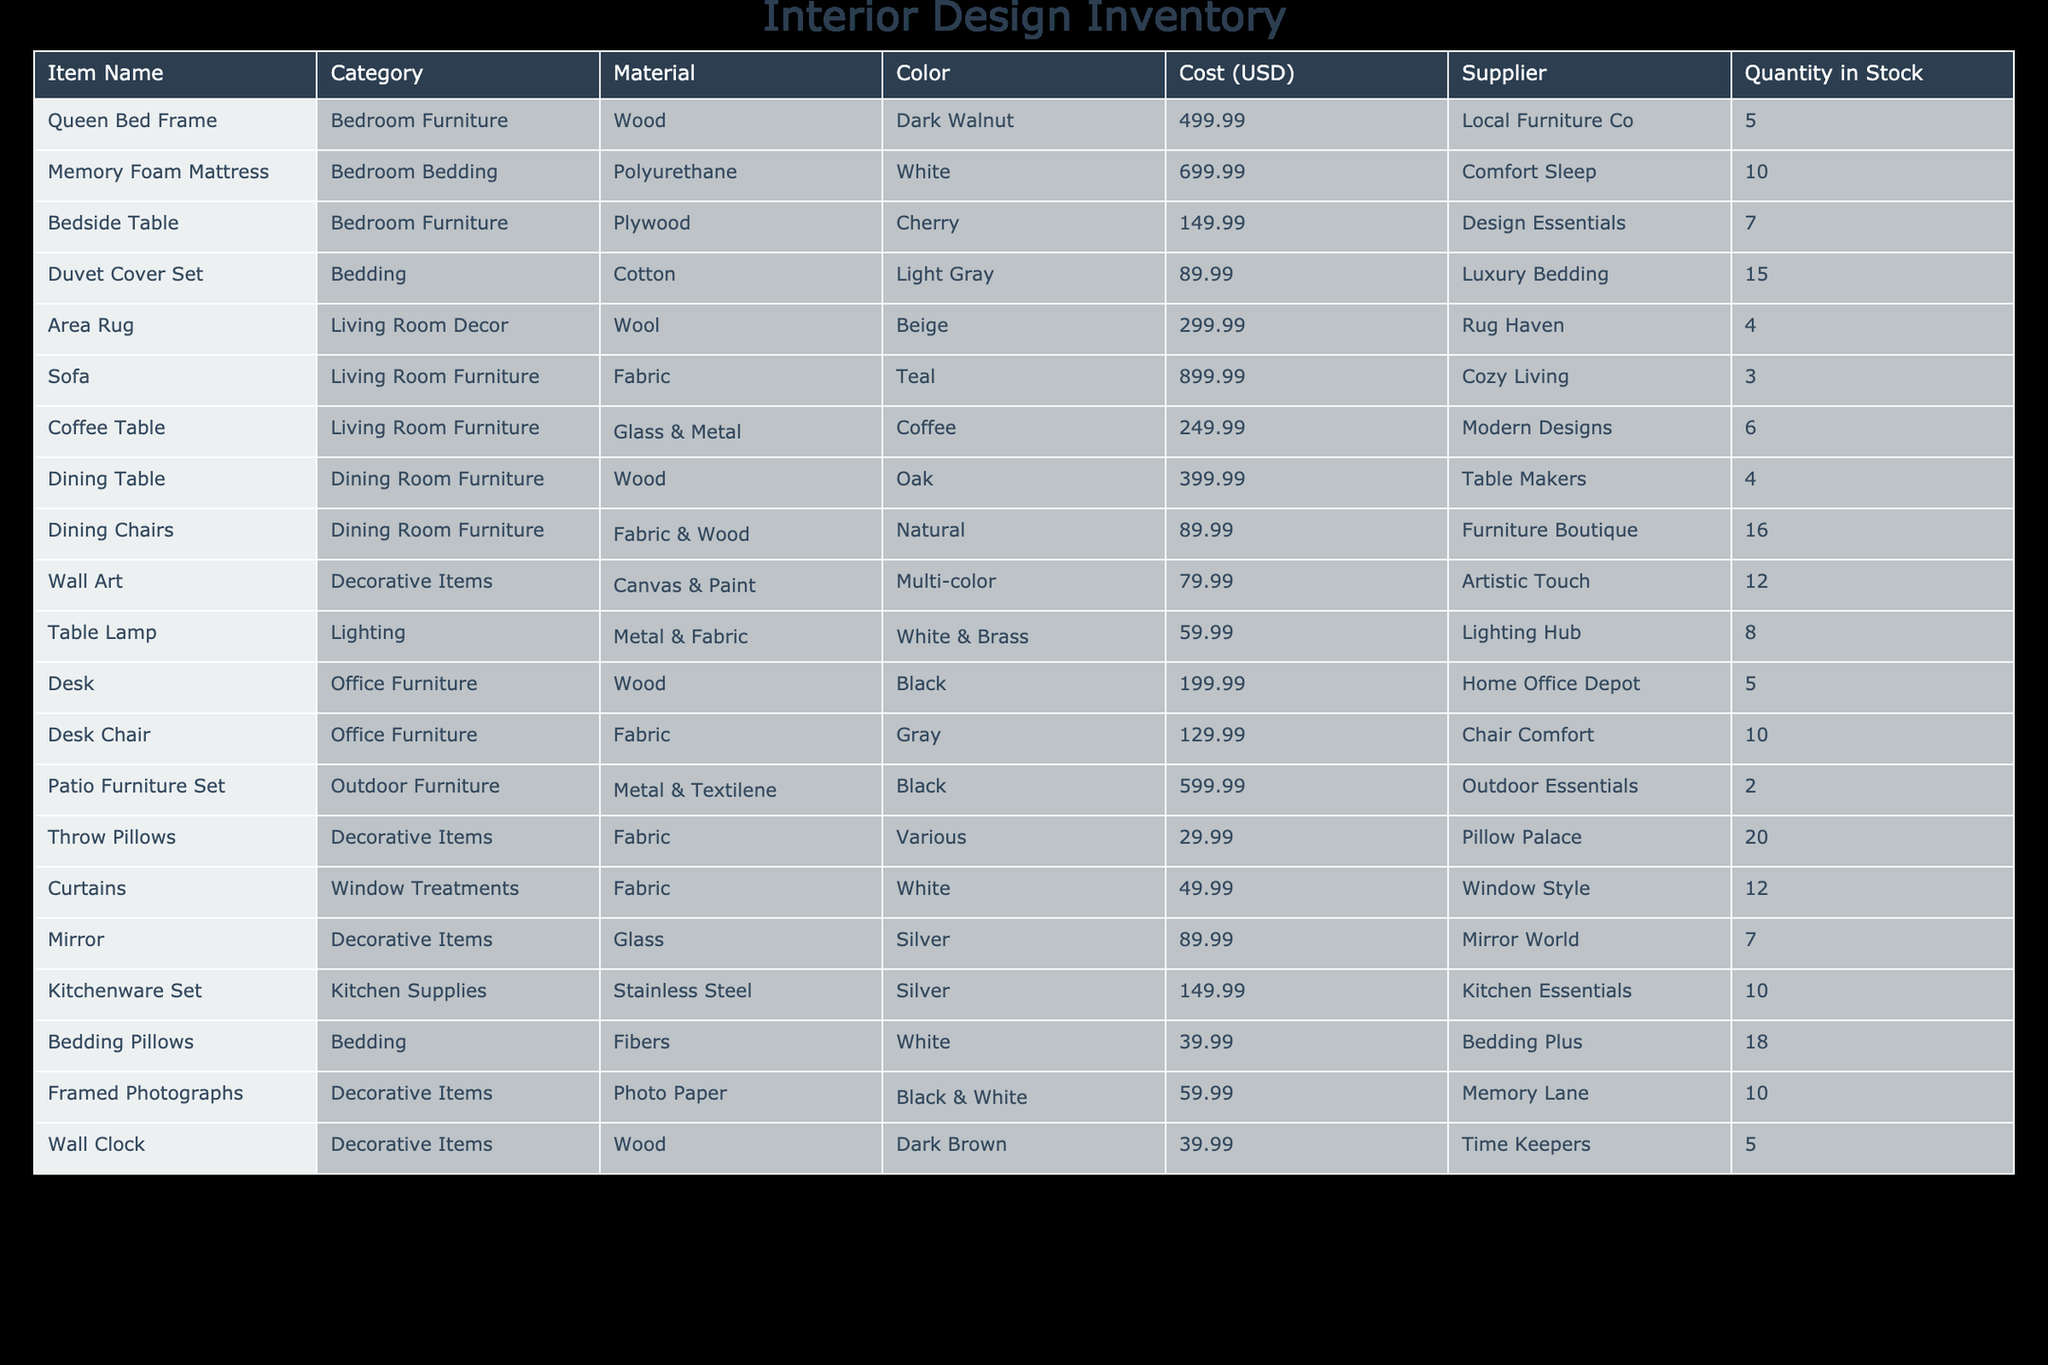What is the total cost of all the bed items in stock? The bed items in stock are the Queen Bed Frame, Memory Foam Mattress, Bedside Table, Duvet Cover Set, and Bedding Pillows. The individual costs are $499.99, $699.99, $149.99, $89.99, and $39.99 respectively. Summing these costs gives $499.99 + $699.99 + $149.99 + $89.99 + $39.99 = $1,579.95.
Answer: 1579.95 Is there more than one type of sofa available? There is only one type of sofa listed in the table, which is a fabric sofa in teal color. There are no other entries for sofas in different styles or colors.
Answer: No How many decorative items are in stock in total? The decorative items listed include Wall Art, Throw Pillows, Mirror, Framed Photographs, and Wall Clock. Their quantities respectively are 12, 20, 7, 10, and 5. Adding these quantities gives 12 + 20 + 7 + 10 + 5 = 54.
Answer: 54 What is the average cost of the dining room furniture? The furniture in this category are the Dining Table costing $399.99 and Dining Chairs costing $89.99. The total cost is $399.99 + $89.99 = $489.98. There are 2 items, so the average cost is $489.98 / 2 = $244.99.
Answer: 244.99 Are there cheaper lighting options than the table lamp? The table lamp costs $59.99. The items listed in the lighting category or similar costs include the Wall Clock at $39.99; since $39.99 is less than $59.99, it is a cheaper option.
Answer: Yes Which item has the largest quantity in stock? The item with the largest quantity in stock is Dining Chairs, with 16 units available. Other items may have higher costs, but quantity-wise, the Dining Chairs surpass others.
Answer: Dining Chairs What is the total cost of all kitchen supplies? The only item in the kitchen supplies category is the Kitchenware Set, which costs $149.99. Since there is only one item, the total cost remains $149.99 without further calculations.
Answer: 149.99 Is the quantity of outdoor furniture greater than the quantity of living room furniture? The outdoor furniture consists of a Patio Furniture Set with a quantity of 2. The living room furniture category includes Sofa (3 units) and Coffee Table (6 units), totaling 9 units. Since 9 is greater than 2, outdoor furniture quantity is less.
Answer: No What is the total cost of all furniture items combined? The furniture items are Queen Bed Frame ($499.99), Bedside Table ($149.99), Sofa ($899.99), Dining Table ($399.99), Dining Chairs ($89.99), Desk ($199.99), Desk Chair ($129.99), and Patio Furniture Set ($599.99). Adding these together yields $499.99 + $149.99 + $899.99 + $399.99 + $89.99 + $199.99 + $129.99 + $599.99 = $2,359.92.
Answer: 2359.92 